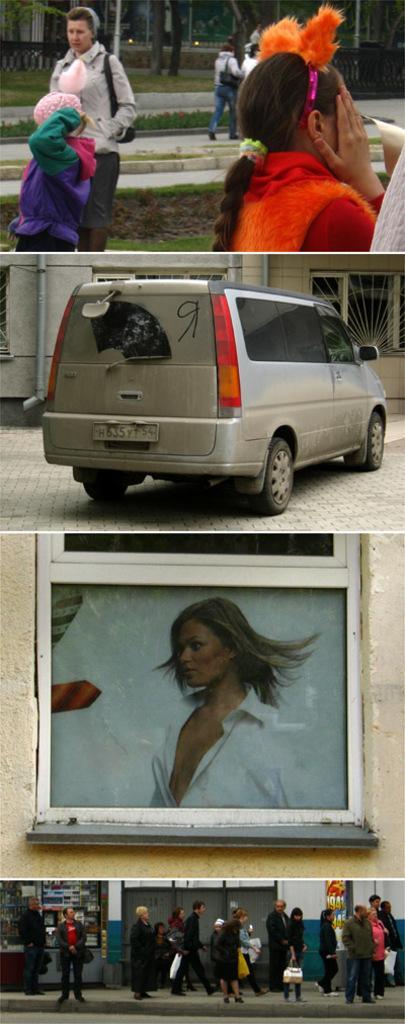Can you describe this image briefly? In the image in the center, we can see one vehicle, building, wall and photo frame. On the top of the image we can see a few people are standing. At the bottom of the image, there is a building and few people are walking. 